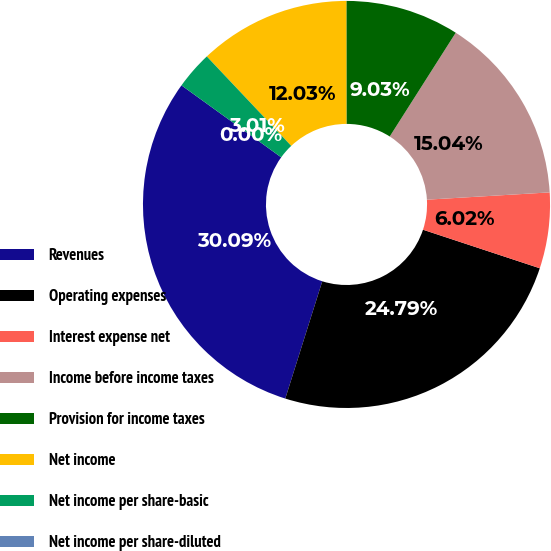<chart> <loc_0><loc_0><loc_500><loc_500><pie_chart><fcel>Revenues<fcel>Operating expenses<fcel>Interest expense net<fcel>Income before income taxes<fcel>Provision for income taxes<fcel>Net income<fcel>Net income per share-basic<fcel>Net income per share-diluted<nl><fcel>30.09%<fcel>24.79%<fcel>6.02%<fcel>15.04%<fcel>9.03%<fcel>12.03%<fcel>3.01%<fcel>0.0%<nl></chart> 